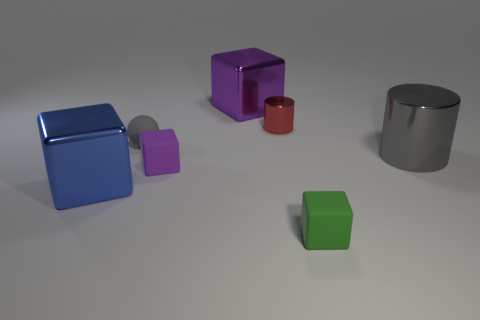Is the number of big blocks that are left of the purple metal cube less than the number of purple objects that are to the left of the gray cylinder?
Provide a succinct answer. Yes. What size is the blue thing that is the same shape as the tiny green object?
Provide a succinct answer. Large. Is there any other thing that is the same size as the sphere?
Give a very brief answer. Yes. How many things are matte cubes that are on the left side of the purple metal object or large metal things right of the big purple object?
Your answer should be very brief. 2. Is the size of the purple shiny thing the same as the gray metallic cylinder?
Provide a succinct answer. Yes. Is the number of blue rubber spheres greater than the number of small matte cubes?
Make the answer very short. No. What number of other things are there of the same color as the sphere?
Give a very brief answer. 1. What number of objects are tiny metal balls or tiny gray objects?
Your answer should be compact. 1. Does the small object that is in front of the blue block have the same shape as the large purple shiny object?
Your answer should be very brief. Yes. There is a small rubber object that is on the right side of the metal cube that is behind the gray metal cylinder; what color is it?
Your answer should be compact. Green. 